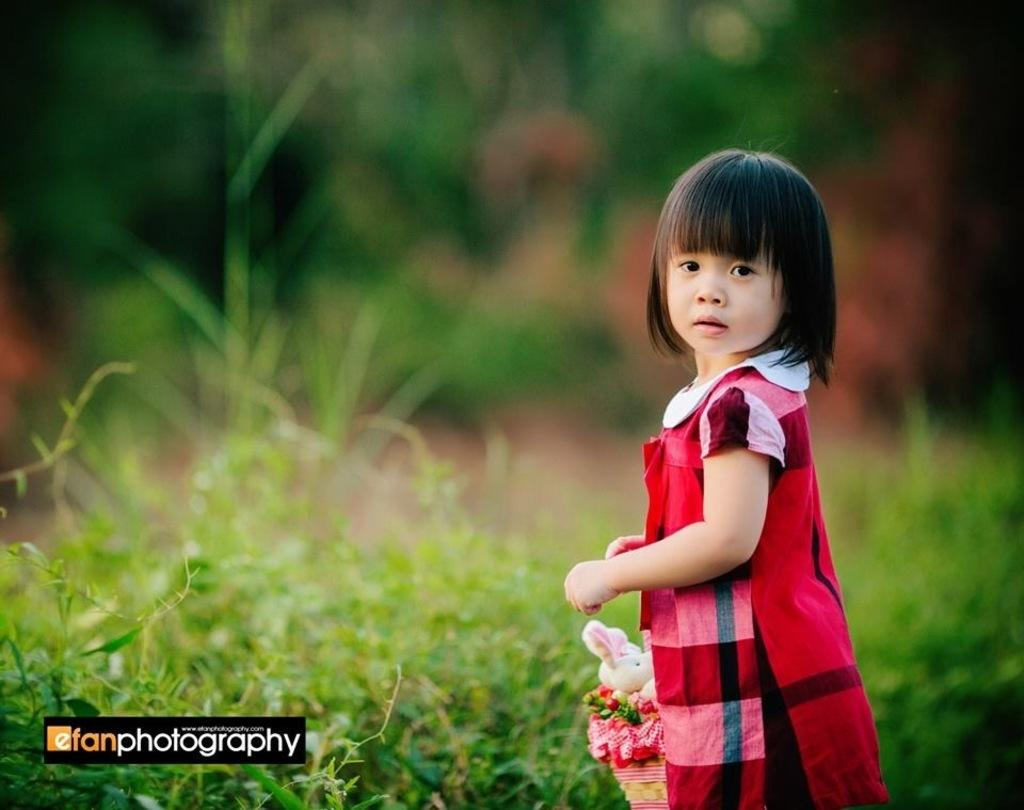<image>
Write a terse but informative summary of the picture. A girl on a green background copyrighted by efanphotography 